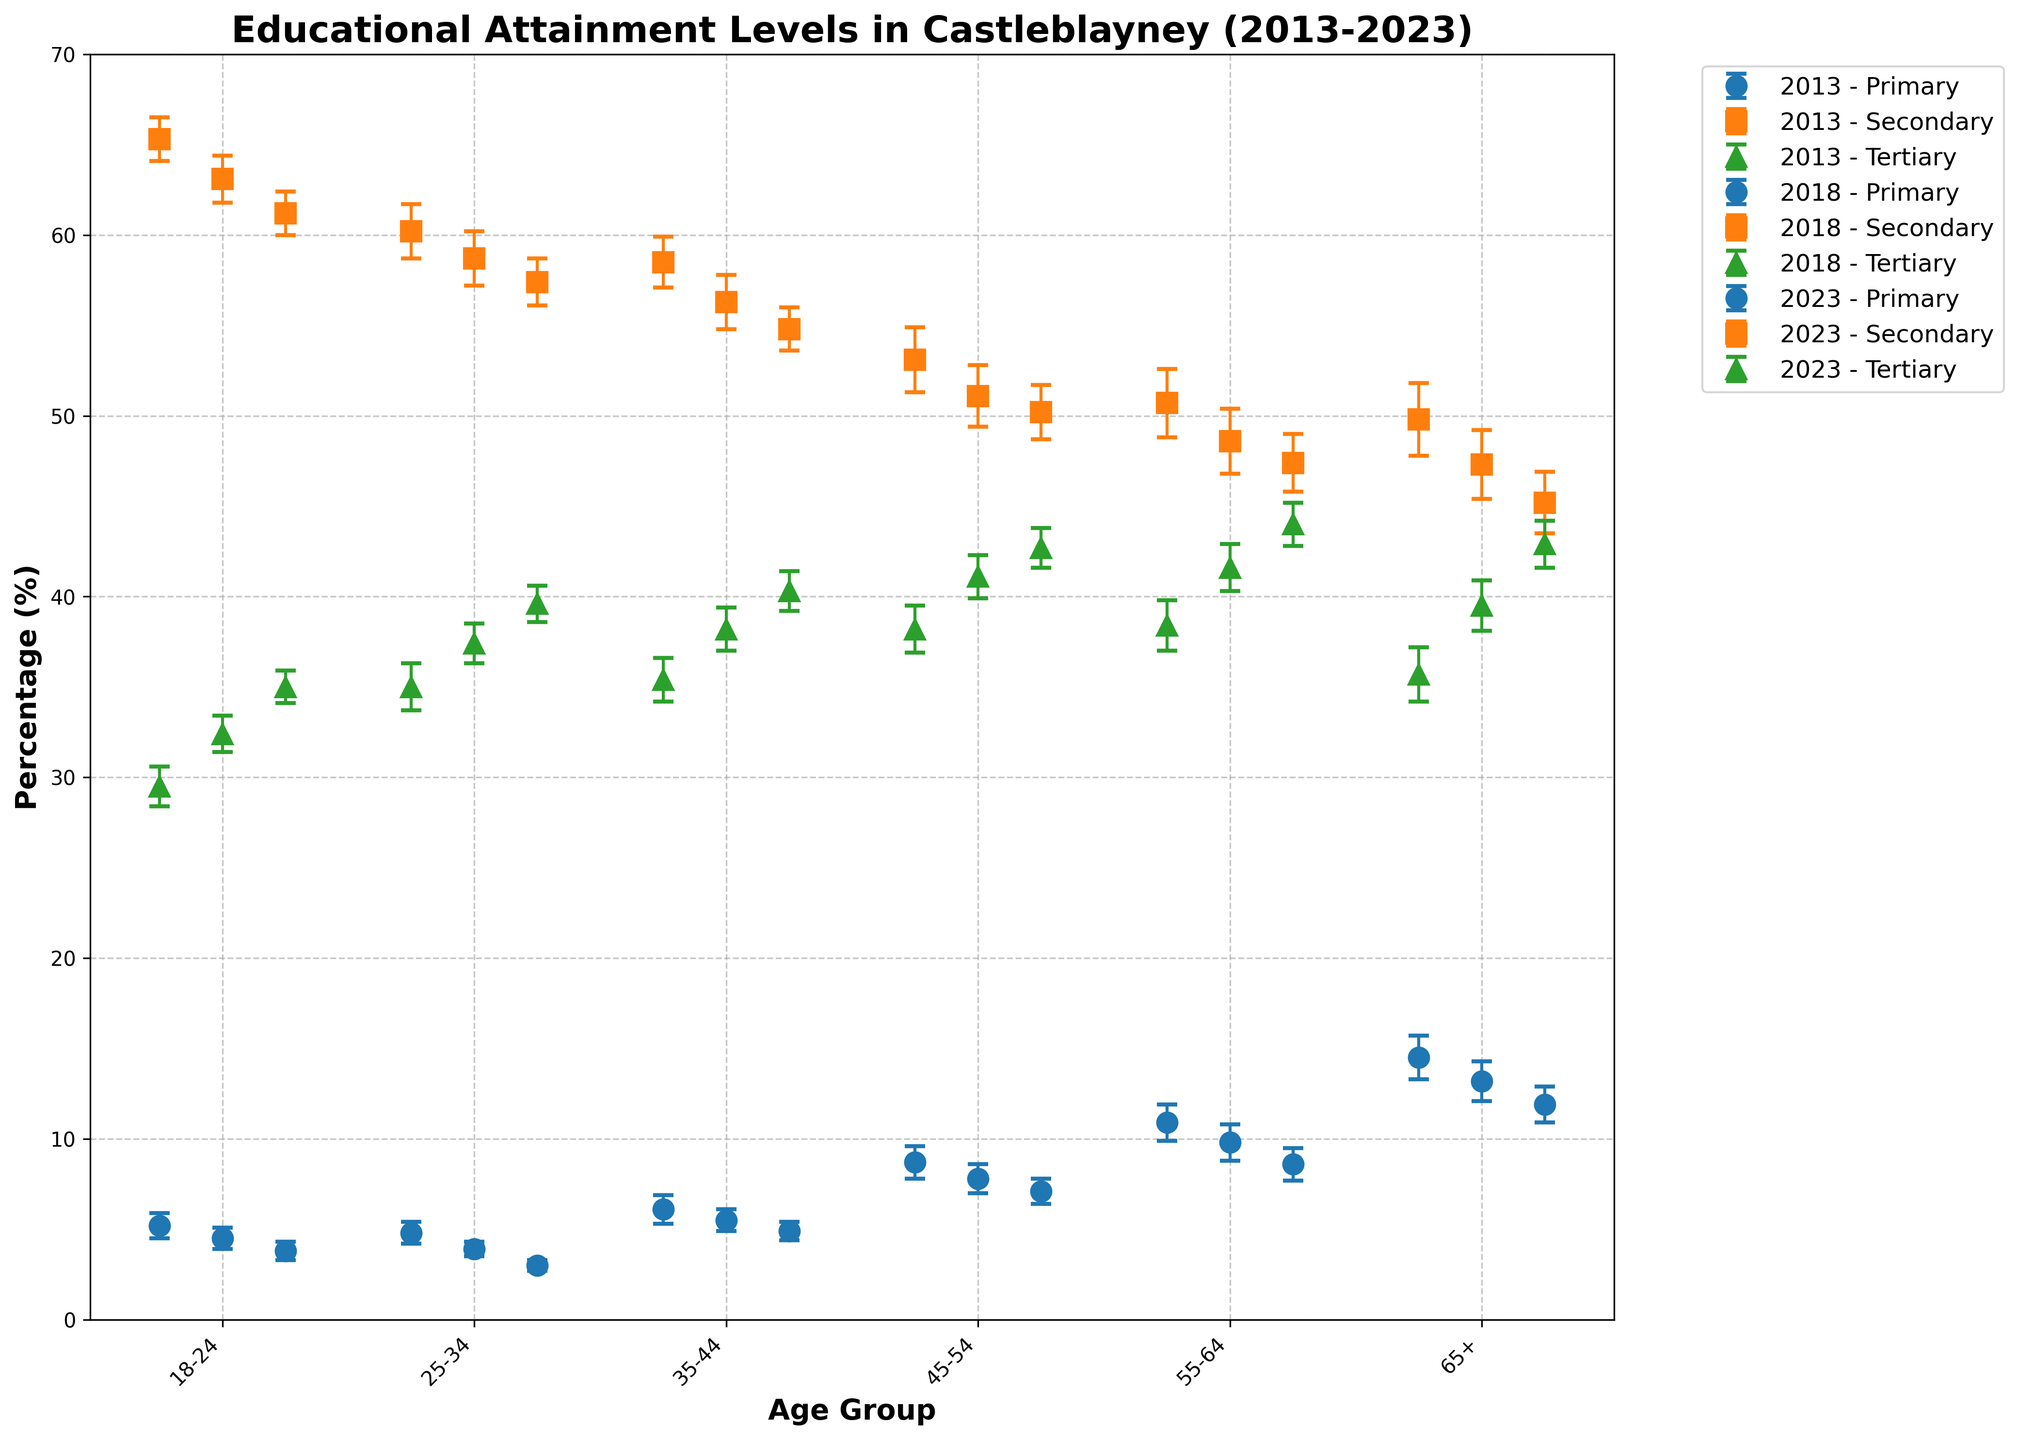How many age groups are analyzed in the figure? The figure has labels for different age groups on the x-axis. By counting these labels, we can determine the number of age groups analyzed.
Answer: 6 What is the general trend of primary education attainment for the 65+ age group from 2013 to 2023? To identify the trend, we will look at the dot plot for the 'Primary' education level and the 65+ age group from 2013 to 2023; observe the direction of change over these years. In 2013, the value is 14.5%, decreasing to 13.2% in 2018, and further decreasing to 11.9% in 2023, indicating a general downward trend.
Answer: Decreasing Which education level has seen the highest increase for the 25-34 age group from 2013 to 2023? By examining the dot plot points for each education level (Primary, Secondary, Tertiary) for the 25-34 age group across the years (2013, 2018, 2023), we can compare the percentage values in each year. The Tertiary level increased from 35.0% in 2013 to 39.6% in 2023.
Answer: Tertiary In which year did the 55-64 age group have the highest tertiary education level? Look at the dot plots for the 'Tertiary' education level in the 55-64 age group over different years. Compare the means: 38.4% (2013), 41.6% (2018), and 44.0% (2023). The highest value is in 2023.
Answer: 2023 What is the change in secondary education percentage for the 18-24 age group from 2013 to 2023? First, find the secondary education percentages for the 18-24 age group in 2013 (65.3%) and in 2023 (61.2%). Then, subtract the latter from the former: 65.3% - 61.2% = 4.1%.
Answer: 4.1% How does the primary education level in 2023 compare between the 18-24 and 45-54 age groups? Look at the primary education level dots for these age groups in 2023: 3.8% (18-24) and 7.1% (45-54). The 45-54 age group has a higher percentage.
Answer: Higher for 45-54 Which age group shows the most variation in secondary education levels across 2013-2023 based on error bars? Assess the sizes of the error bars for secondary education levels in each age group across the years. The lengthiest error bars signify the greatest variation. From observation, the 45-54 and 55-64 age groups have the most prominent error bars.
Answer: 45-54 and 55-64 Are tertiary education levels higher for the 35-44 or 55-64 age groups in 2023? Locate the tertiary education dots for these age groups in 2023: 40.3% for 35-44 and 44.0% for 55-64. The 55-64 age group has the higher value.
Answer: 55-64 What is the primary education level percentage for the 35-44 age group in 2023 compared to 2018? Check the primary education dots for the 35-44 age group: it is 4.9% in 2023 and 5.5% in 2018. Subtraction shows a decrease: 5.5% - 4.9% = 0.6%.
Answer: 0.6% decrease What education level shows the least change for the 65+ group from 2013 to 2023? By evaluating the changes for all three levels for the 65+ group: Primary from 14.5% to 11.9% (2.6%), Secondary from 49.8% to 45.2% (4.6%), Tertiary from 35.7% to 42.9% (7.2%). The Primary level sees the smallest change (2.6% decrease).
Answer: Primary 